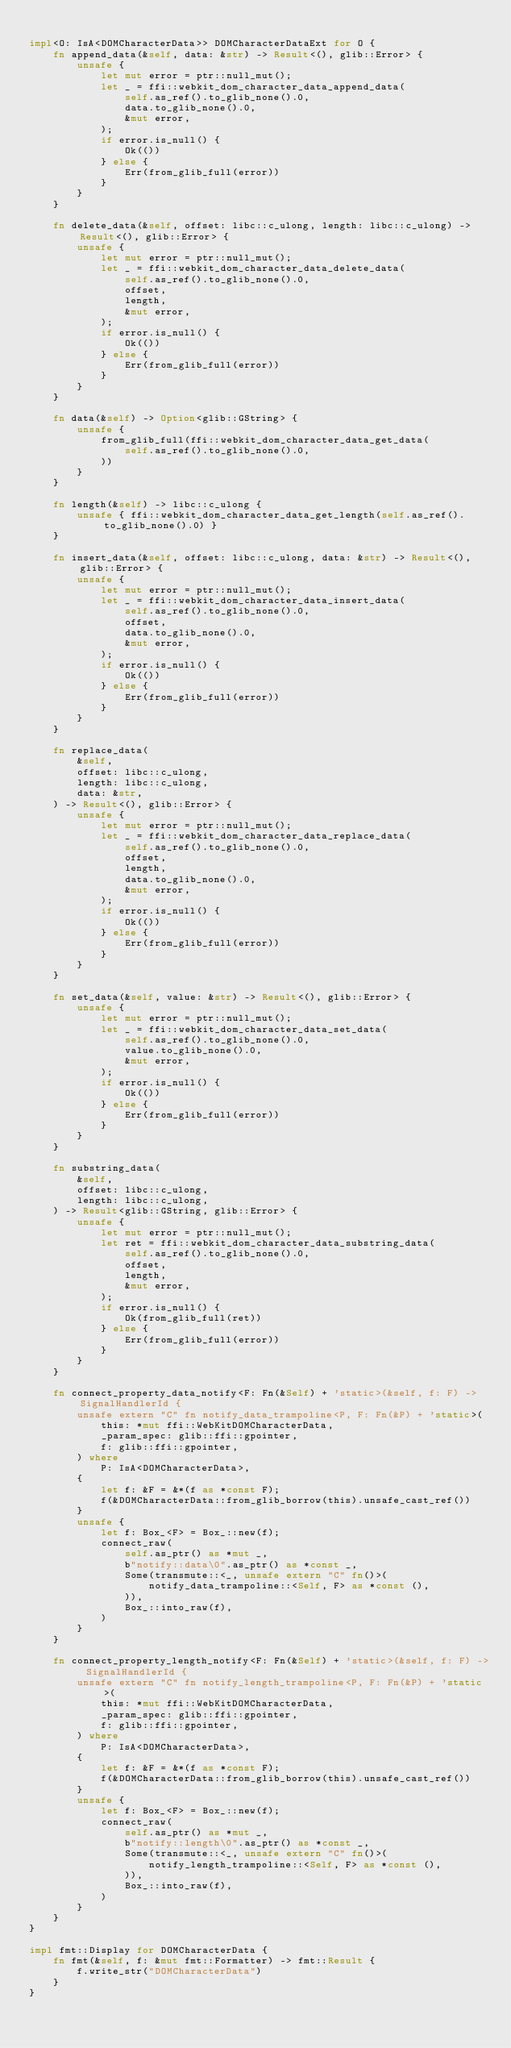Convert code to text. <code><loc_0><loc_0><loc_500><loc_500><_Rust_>
impl<O: IsA<DOMCharacterData>> DOMCharacterDataExt for O {
    fn append_data(&self, data: &str) -> Result<(), glib::Error> {
        unsafe {
            let mut error = ptr::null_mut();
            let _ = ffi::webkit_dom_character_data_append_data(
                self.as_ref().to_glib_none().0,
                data.to_glib_none().0,
                &mut error,
            );
            if error.is_null() {
                Ok(())
            } else {
                Err(from_glib_full(error))
            }
        }
    }

    fn delete_data(&self, offset: libc::c_ulong, length: libc::c_ulong) -> Result<(), glib::Error> {
        unsafe {
            let mut error = ptr::null_mut();
            let _ = ffi::webkit_dom_character_data_delete_data(
                self.as_ref().to_glib_none().0,
                offset,
                length,
                &mut error,
            );
            if error.is_null() {
                Ok(())
            } else {
                Err(from_glib_full(error))
            }
        }
    }

    fn data(&self) -> Option<glib::GString> {
        unsafe {
            from_glib_full(ffi::webkit_dom_character_data_get_data(
                self.as_ref().to_glib_none().0,
            ))
        }
    }

    fn length(&self) -> libc::c_ulong {
        unsafe { ffi::webkit_dom_character_data_get_length(self.as_ref().to_glib_none().0) }
    }

    fn insert_data(&self, offset: libc::c_ulong, data: &str) -> Result<(), glib::Error> {
        unsafe {
            let mut error = ptr::null_mut();
            let _ = ffi::webkit_dom_character_data_insert_data(
                self.as_ref().to_glib_none().0,
                offset,
                data.to_glib_none().0,
                &mut error,
            );
            if error.is_null() {
                Ok(())
            } else {
                Err(from_glib_full(error))
            }
        }
    }

    fn replace_data(
        &self,
        offset: libc::c_ulong,
        length: libc::c_ulong,
        data: &str,
    ) -> Result<(), glib::Error> {
        unsafe {
            let mut error = ptr::null_mut();
            let _ = ffi::webkit_dom_character_data_replace_data(
                self.as_ref().to_glib_none().0,
                offset,
                length,
                data.to_glib_none().0,
                &mut error,
            );
            if error.is_null() {
                Ok(())
            } else {
                Err(from_glib_full(error))
            }
        }
    }

    fn set_data(&self, value: &str) -> Result<(), glib::Error> {
        unsafe {
            let mut error = ptr::null_mut();
            let _ = ffi::webkit_dom_character_data_set_data(
                self.as_ref().to_glib_none().0,
                value.to_glib_none().0,
                &mut error,
            );
            if error.is_null() {
                Ok(())
            } else {
                Err(from_glib_full(error))
            }
        }
    }

    fn substring_data(
        &self,
        offset: libc::c_ulong,
        length: libc::c_ulong,
    ) -> Result<glib::GString, glib::Error> {
        unsafe {
            let mut error = ptr::null_mut();
            let ret = ffi::webkit_dom_character_data_substring_data(
                self.as_ref().to_glib_none().0,
                offset,
                length,
                &mut error,
            );
            if error.is_null() {
                Ok(from_glib_full(ret))
            } else {
                Err(from_glib_full(error))
            }
        }
    }

    fn connect_property_data_notify<F: Fn(&Self) + 'static>(&self, f: F) -> SignalHandlerId {
        unsafe extern "C" fn notify_data_trampoline<P, F: Fn(&P) + 'static>(
            this: *mut ffi::WebKitDOMCharacterData,
            _param_spec: glib::ffi::gpointer,
            f: glib::ffi::gpointer,
        ) where
            P: IsA<DOMCharacterData>,
        {
            let f: &F = &*(f as *const F);
            f(&DOMCharacterData::from_glib_borrow(this).unsafe_cast_ref())
        }
        unsafe {
            let f: Box_<F> = Box_::new(f);
            connect_raw(
                self.as_ptr() as *mut _,
                b"notify::data\0".as_ptr() as *const _,
                Some(transmute::<_, unsafe extern "C" fn()>(
                    notify_data_trampoline::<Self, F> as *const (),
                )),
                Box_::into_raw(f),
            )
        }
    }

    fn connect_property_length_notify<F: Fn(&Self) + 'static>(&self, f: F) -> SignalHandlerId {
        unsafe extern "C" fn notify_length_trampoline<P, F: Fn(&P) + 'static>(
            this: *mut ffi::WebKitDOMCharacterData,
            _param_spec: glib::ffi::gpointer,
            f: glib::ffi::gpointer,
        ) where
            P: IsA<DOMCharacterData>,
        {
            let f: &F = &*(f as *const F);
            f(&DOMCharacterData::from_glib_borrow(this).unsafe_cast_ref())
        }
        unsafe {
            let f: Box_<F> = Box_::new(f);
            connect_raw(
                self.as_ptr() as *mut _,
                b"notify::length\0".as_ptr() as *const _,
                Some(transmute::<_, unsafe extern "C" fn()>(
                    notify_length_trampoline::<Self, F> as *const (),
                )),
                Box_::into_raw(f),
            )
        }
    }
}

impl fmt::Display for DOMCharacterData {
    fn fmt(&self, f: &mut fmt::Formatter) -> fmt::Result {
        f.write_str("DOMCharacterData")
    }
}
</code> 